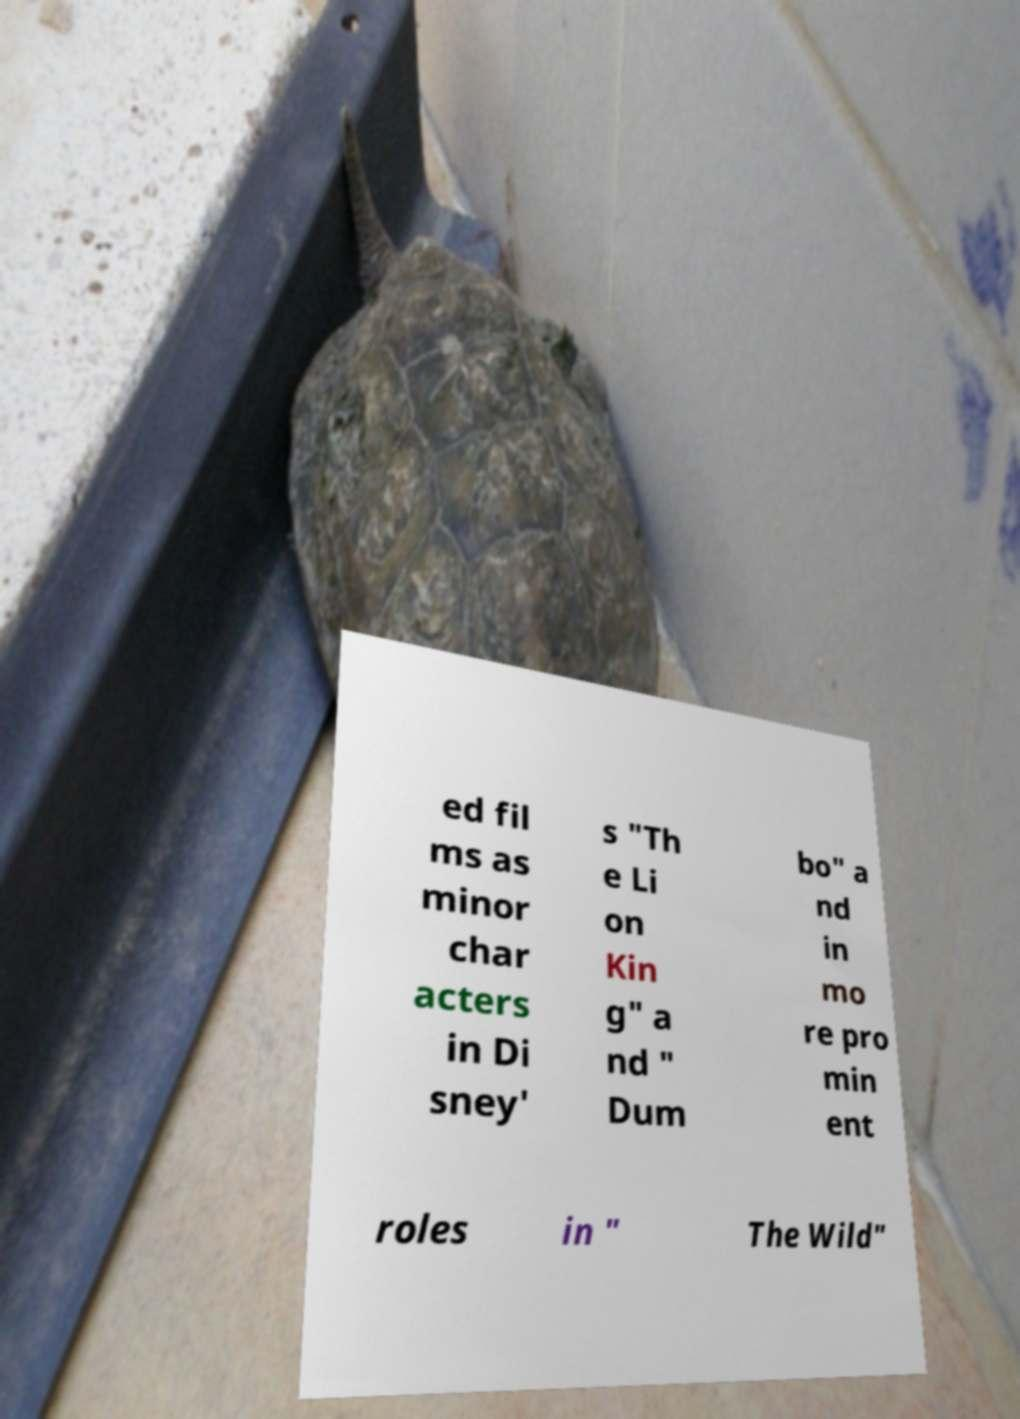For documentation purposes, I need the text within this image transcribed. Could you provide that? ed fil ms as minor char acters in Di sney' s "Th e Li on Kin g" a nd " Dum bo" a nd in mo re pro min ent roles in " The Wild" 